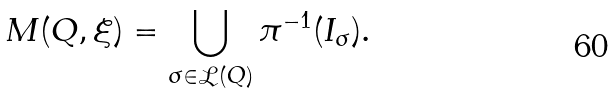Convert formula to latex. <formula><loc_0><loc_0><loc_500><loc_500>M ( Q , \xi ) = \bigcup _ { \sigma \in \mathcal { L } ( Q ) } \pi ^ { - 1 } ( I _ { \sigma } ) .</formula> 